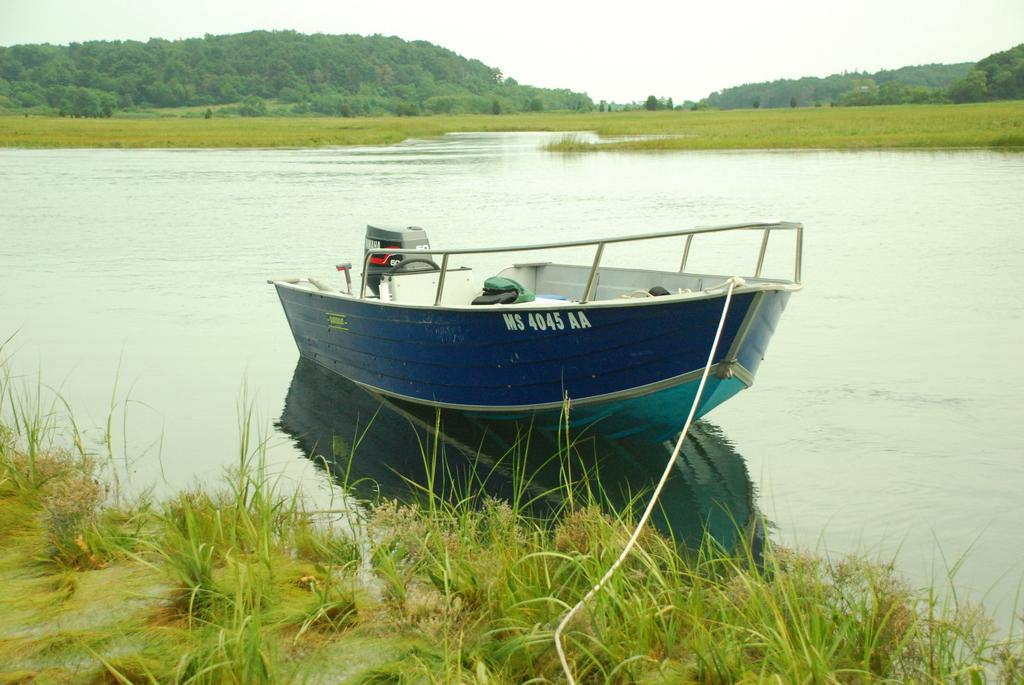What is there is a boat in the image, where is it located? The boat is on water in the image. What can be seen in the background of the image? There are mountains, trees, and the sky visible in the background of the image. What is at the bottom of the image? There is grass at the bottom of the image. Can you see any bread or bones in the image? No, there is no bread or bones present in the image. Is there a deer visible in the image? No, there is no deer present in the image. 